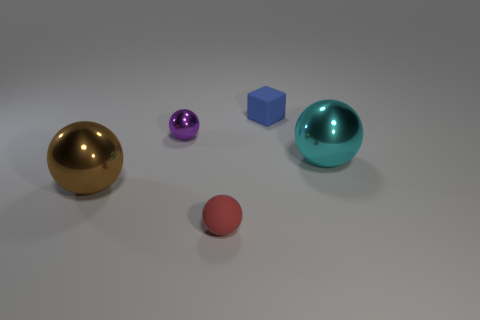Is the number of red things to the right of the blue thing less than the number of tiny blue matte things?
Ensure brevity in your answer.  Yes. There is a tiny red matte object; how many big shiny spheres are on the right side of it?
Offer a very short reply. 1. What is the size of the sphere behind the shiny sphere to the right of the small matte thing that is in front of the small blue rubber cube?
Provide a succinct answer. Small. There is a tiny purple shiny object; is its shape the same as the matte object in front of the big brown sphere?
Offer a terse response. Yes. There is a object that is the same material as the red sphere; what is its size?
Offer a very short reply. Small. Is there anything else that has the same color as the block?
Your response must be concise. No. There is a big thing that is behind the large sphere in front of the metallic sphere on the right side of the red object; what is its material?
Give a very brief answer. Metal. How many rubber things are small red balls or brown cubes?
Your answer should be very brief. 1. Is the color of the matte block the same as the matte ball?
Offer a very short reply. No. Is there anything else that has the same material as the small blue cube?
Your answer should be compact. Yes. 